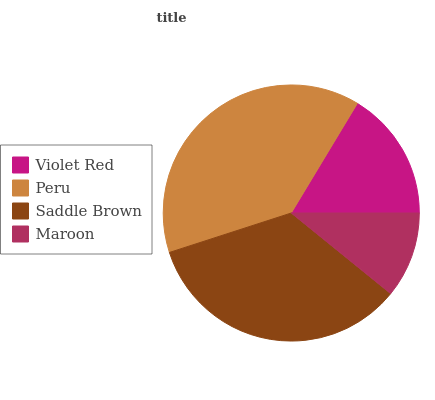Is Maroon the minimum?
Answer yes or no. Yes. Is Peru the maximum?
Answer yes or no. Yes. Is Saddle Brown the minimum?
Answer yes or no. No. Is Saddle Brown the maximum?
Answer yes or no. No. Is Peru greater than Saddle Brown?
Answer yes or no. Yes. Is Saddle Brown less than Peru?
Answer yes or no. Yes. Is Saddle Brown greater than Peru?
Answer yes or no. No. Is Peru less than Saddle Brown?
Answer yes or no. No. Is Saddle Brown the high median?
Answer yes or no. Yes. Is Violet Red the low median?
Answer yes or no. Yes. Is Maroon the high median?
Answer yes or no. No. Is Maroon the low median?
Answer yes or no. No. 